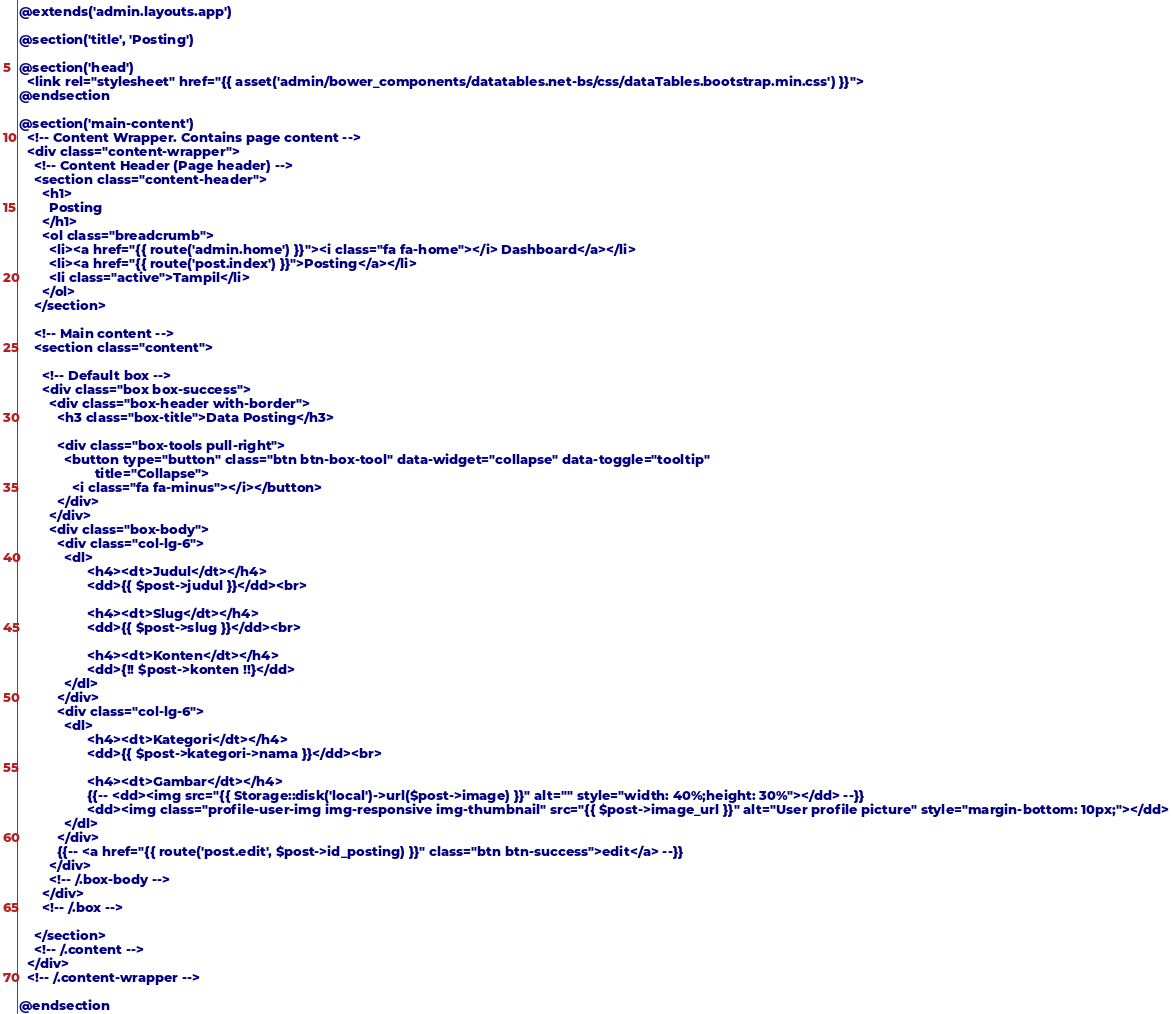<code> <loc_0><loc_0><loc_500><loc_500><_PHP_>@extends('admin.layouts.app')

@section('title', 'Posting')

@section('head')
  <link rel="stylesheet" href="{{ asset('admin/bower_components/datatables.net-bs/css/dataTables.bootstrap.min.css') }}">
@endsection

@section('main-content')
  <!-- Content Wrapper. Contains page content -->
  <div class="content-wrapper">
    <!-- Content Header (Page header) -->
    <section class="content-header">
      <h1>
        Posting
      </h1>
      <ol class="breadcrumb">
        <li><a href="{{ route('admin.home') }}"><i class="fa fa-home"></i> Dashboard</a></li>
        <li><a href="{{ route('post.index') }}">Posting</a></li>
        <li class="active">Tampil</li>
      </ol>
    </section>

    <!-- Main content -->
    <section class="content">

      <!-- Default box -->
      <div class="box box-success">
        <div class="box-header with-border">
          <h3 class="box-title">Data Posting</h3>

          <div class="box-tools pull-right">
            <button type="button" class="btn btn-box-tool" data-widget="collapse" data-toggle="tooltip"
                    title="Collapse">
              <i class="fa fa-minus"></i></button>
          </div>
        </div>
        <div class="box-body">
          <div class="col-lg-6">
            <dl>
                  <h4><dt>Judul</dt></h4>
                  <dd>{{ $post->judul }}</dd><br>

                  <h4><dt>Slug</dt></h4>
                  <dd>{{ $post->slug }}</dd><br>

                  <h4><dt>Konten</dt></h4>
                  <dd>{!! $post->konten !!}</dd>
            </dl>
          </div>
          <div class="col-lg-6">
            <dl>
                  <h4><dt>Kategori</dt></h4>
                  <dd>{{ $post->kategori->nama }}</dd><br>

                  <h4><dt>Gambar</dt></h4>
                  {{-- <dd><img src="{{ Storage::disk('local')->url($post->image) }}" alt="" style="width: 40%;height: 30%"></dd> --}}
                  <dd><img class="profile-user-img img-responsive img-thumbnail" src="{{ $post->image_url }}" alt="User profile picture" style="margin-bottom: 10px;"></dd>
            </dl>
          </div>
          {{-- <a href="{{ route('post.edit', $post->id_posting) }}" class="btn btn-success">edit</a> --}}
        </div>
        <!-- /.box-body -->
      </div>
      <!-- /.box -->

    </section>
    <!-- /.content -->
  </div>
  <!-- /.content-wrapper -->

@endsection
</code> 